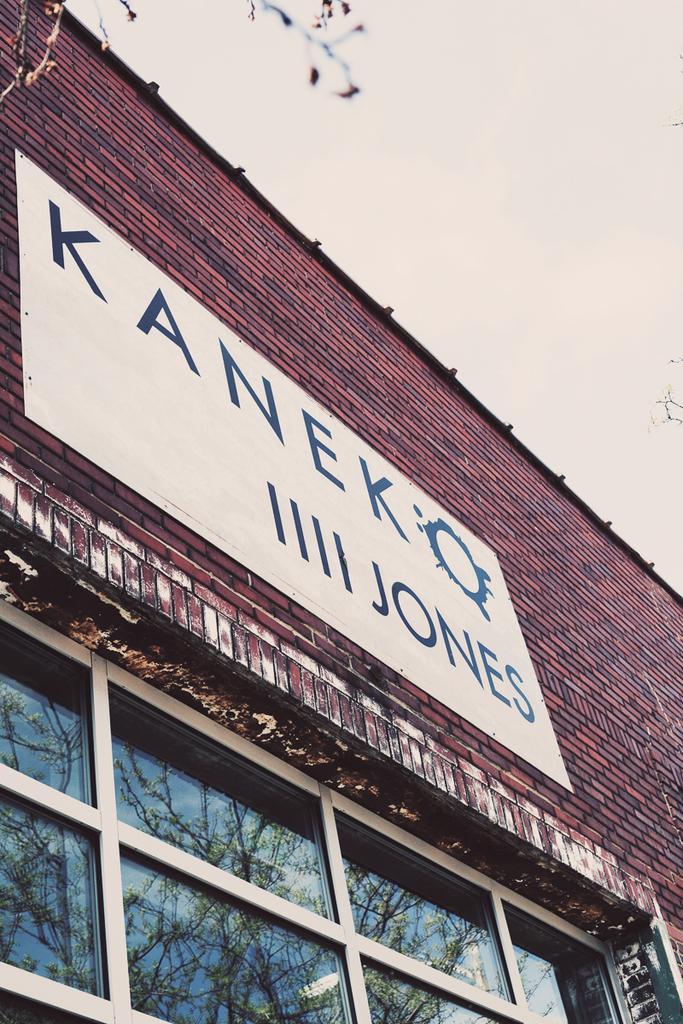Could you give a brief overview of what you see in this image? In the image there is a building with window on the bottom and a name board above it and over the top its sky. 